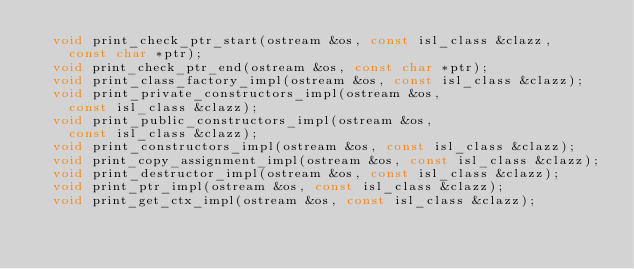Convert code to text. <code><loc_0><loc_0><loc_500><loc_500><_C_>	void print_check_ptr_start(ostream &os, const isl_class &clazz,
		const char *ptr);
	void print_check_ptr_end(ostream &os, const char *ptr);
	void print_class_factory_impl(ostream &os, const isl_class &clazz);
	void print_private_constructors_impl(ostream &os,
		const isl_class &clazz);
	void print_public_constructors_impl(ostream &os,
		const isl_class &clazz);
	void print_constructors_impl(ostream &os, const isl_class &clazz);
	void print_copy_assignment_impl(ostream &os, const isl_class &clazz);
	void print_destructor_impl(ostream &os, const isl_class &clazz);
	void print_ptr_impl(ostream &os, const isl_class &clazz);
	void print_get_ctx_impl(ostream &os, const isl_class &clazz);</code> 